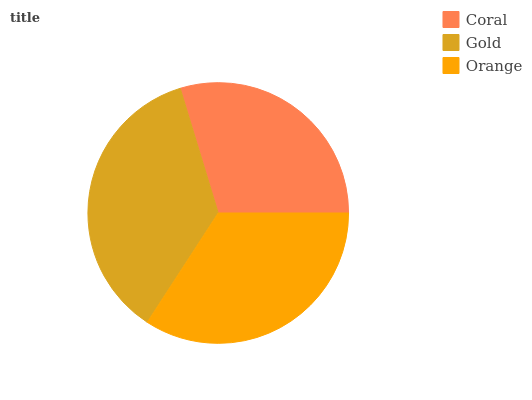Is Coral the minimum?
Answer yes or no. Yes. Is Gold the maximum?
Answer yes or no. Yes. Is Orange the minimum?
Answer yes or no. No. Is Orange the maximum?
Answer yes or no. No. Is Gold greater than Orange?
Answer yes or no. Yes. Is Orange less than Gold?
Answer yes or no. Yes. Is Orange greater than Gold?
Answer yes or no. No. Is Gold less than Orange?
Answer yes or no. No. Is Orange the high median?
Answer yes or no. Yes. Is Orange the low median?
Answer yes or no. Yes. Is Gold the high median?
Answer yes or no. No. Is Gold the low median?
Answer yes or no. No. 